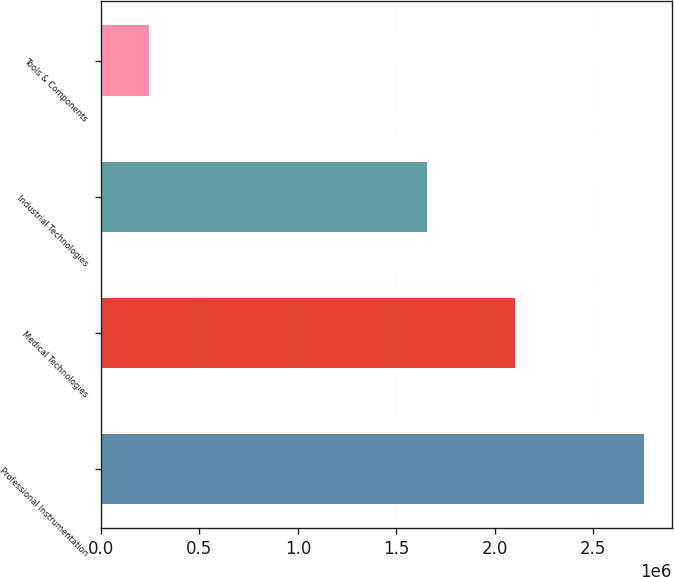<chart> <loc_0><loc_0><loc_500><loc_500><bar_chart><fcel>Professional Instrumentation<fcel>Medical Technologies<fcel>Industrial Technologies<fcel>Tools & Components<nl><fcel>2.75846e+06<fcel>2.1029e+06<fcel>1.65319e+06<fcel>246301<nl></chart> 